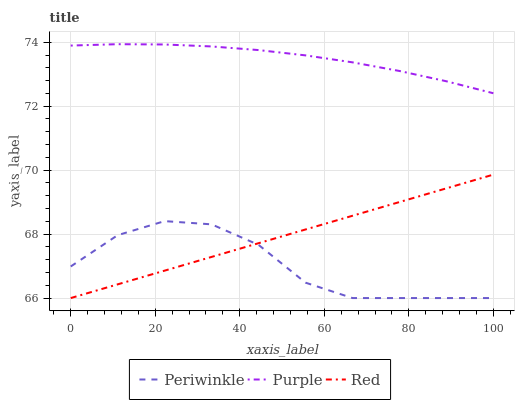Does Red have the minimum area under the curve?
Answer yes or no. No. Does Red have the maximum area under the curve?
Answer yes or no. No. Is Periwinkle the smoothest?
Answer yes or no. No. Is Red the roughest?
Answer yes or no. No. Does Red have the highest value?
Answer yes or no. No. Is Red less than Purple?
Answer yes or no. Yes. Is Purple greater than Red?
Answer yes or no. Yes. Does Red intersect Purple?
Answer yes or no. No. 